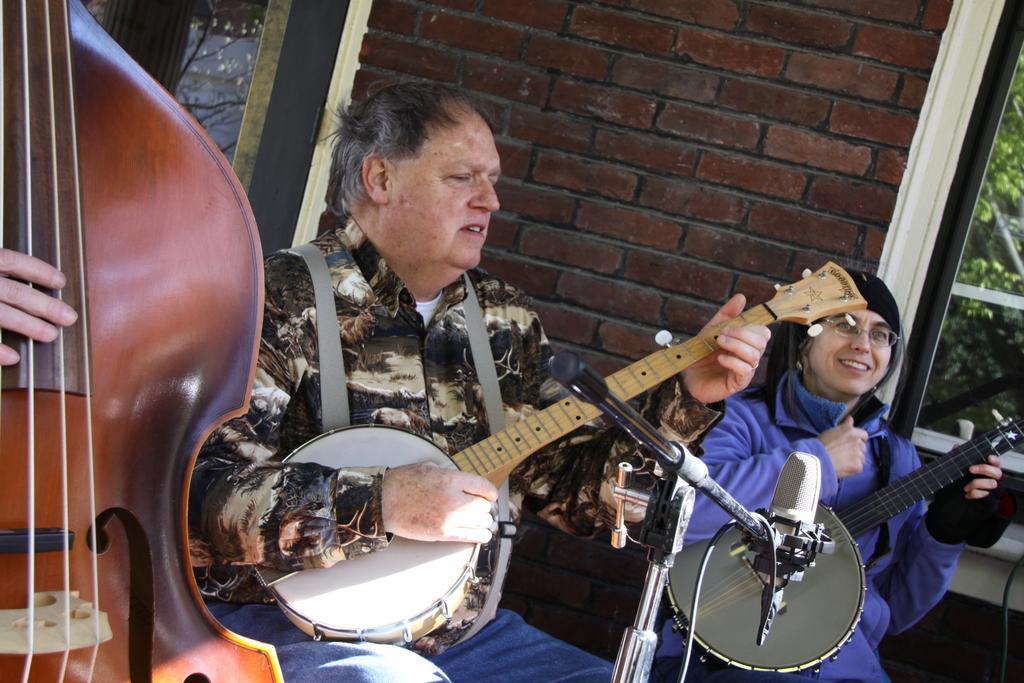Describe this image in one or two sentences. In this picture there is a man in the center holding a sitar and a lady on the right side holding a sitar, there is a guitar and a person on the left side. There are windows, greenery and a wall in the background. 